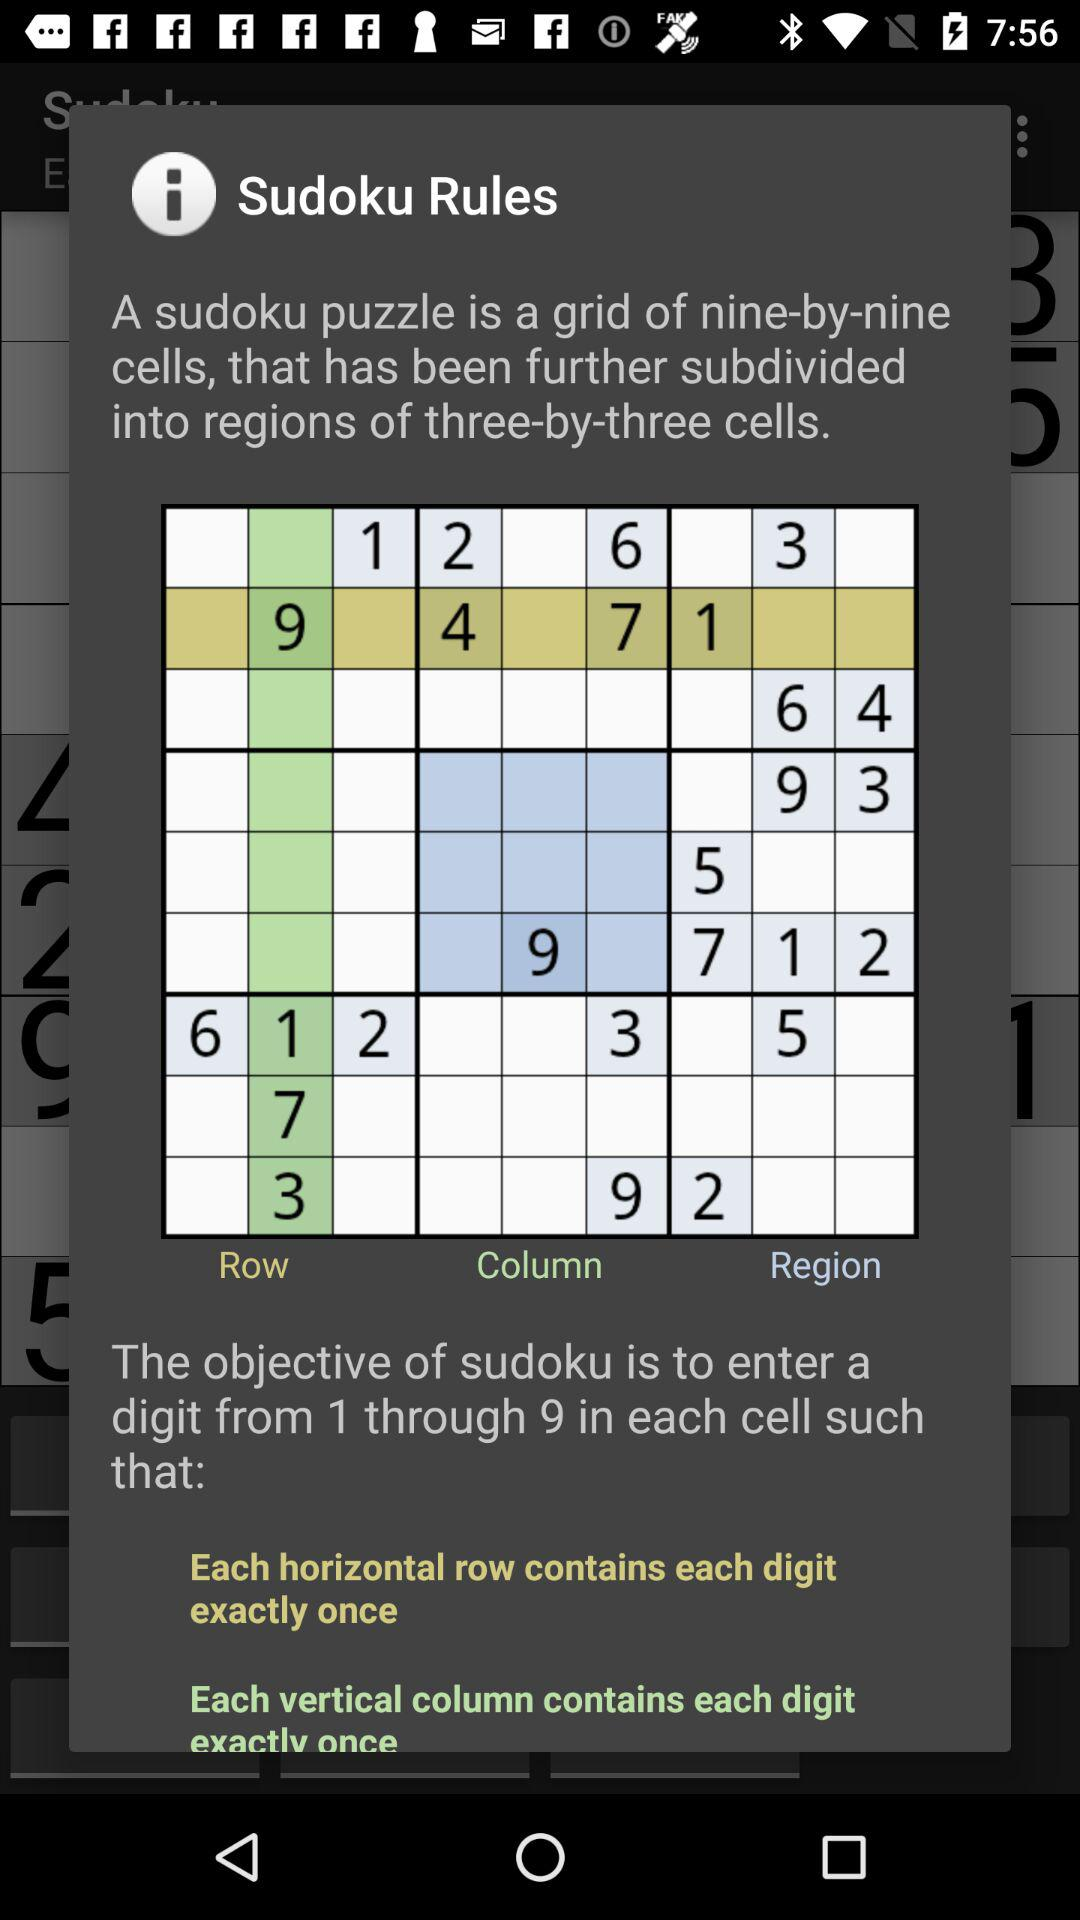How many different regions are there in the sudoku puzzle?
Answer the question using a single word or phrase. 9 